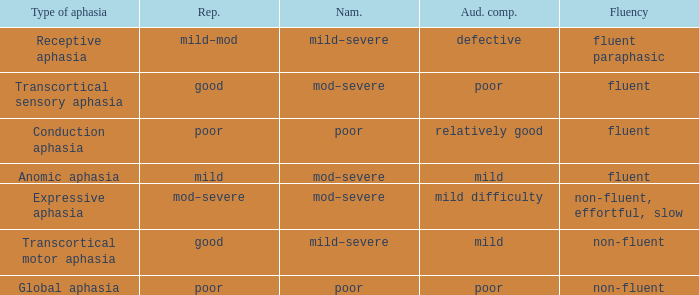Name the naming for fluent and poor comprehension Mod–severe. 